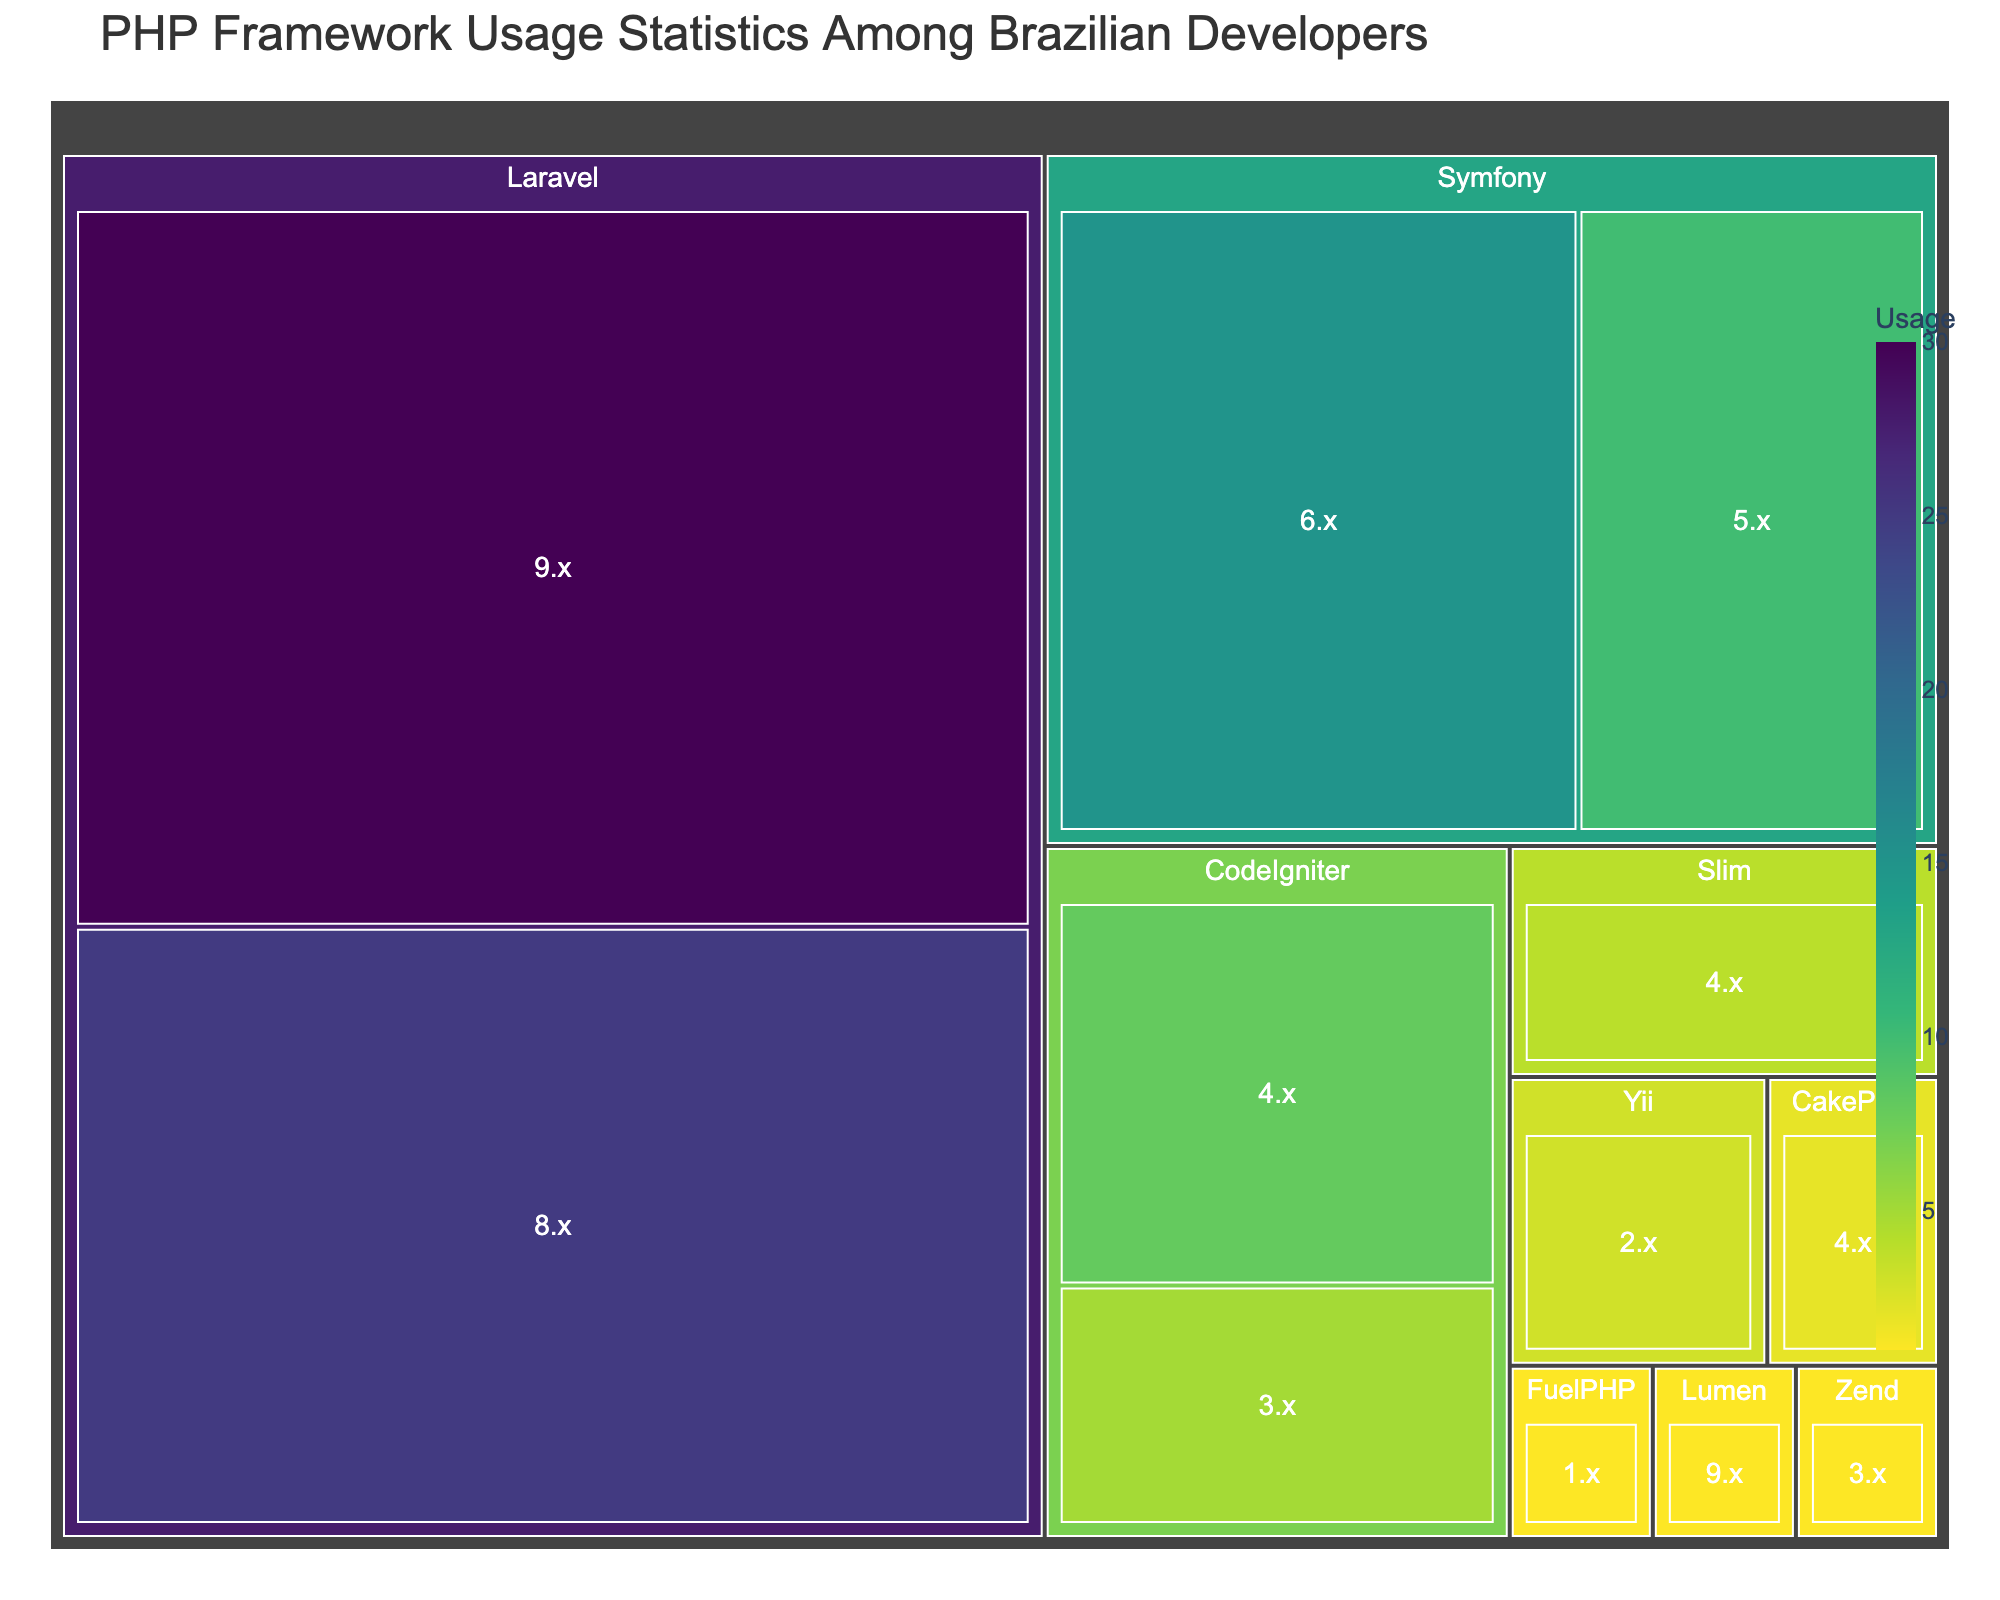What is the title of the Treemap? The title is displayed at the top of the figure and usually gives a summary of what the Treemap represents.
Answer: PHP Framework Usage Statistics Among Brazilian Developers Which PHP framework version has the highest usage? Look at the section that occupies the most space in the Treemap.
Answer: Laravel 9.x Which frameworks are used less than Symfony 5.x? Identify the usage of Symfony 5.x and then look for frameworks with a smaller representation in the Treemap. Frameworks with usage less than 10 include CodeIgniter (both versions), Slim, Yii, CakePHP, Zend, Lumen, and FuelPHP.
Answer: CodeIgniter (4.x, 3.x), Slim 4.x, Yii 2.x, CakePHP 4.x, Zend 3.x, Lumen 9.x, FuelPHP 1.x How much more usage does Laravel 9.x have compared to Laravel 8.x? Subtract the usage of Laravel 8.x from Laravel 9.x usage (30 - 25).
Answer: 5 What's the combined usage of Symfony versions? Add the usage numbers for Symfony 6.x and Symfony 5.x (15 + 10).
Answer: 25 Is the usage of Slim 4.x greater or less than CakePHP 4.x? Compare the sizes of the sections representing Slim 4.x and CakePHP 4.x.
Answer: Greater Identify two frameworks that have the same usage. Look for frameworks with equal-sized sections in the Treemap. Both Zend 3.x and Lumen 9.x have a usage of 1.
Answer: Zend 3.x and Lumen 9.x Which version of CodeIgniter has a higher usage, and by how much? Compare the sections representing CodeIgniter 4.x and CodeIgniter 3.x. CodeIgniter 4.x has 8, and CodeIgniter 3.x has 5. Subtract the lower value from the higher value (8 - 5).
Answer: CodeIgniter 4.x by 3 Out of the frameworks with under 10 usage, which one has the highest? Identify frameworks with usage below 10 and compare their values. CodeIgniter 4.x has the highest usage among them, which is 8.
Answer: CodeIgniter 4.x 